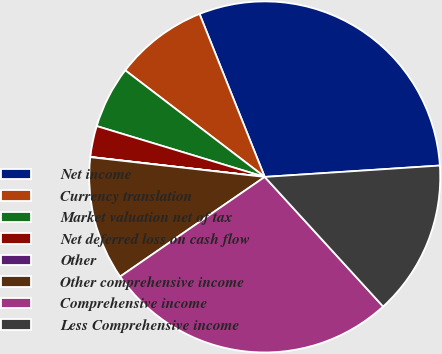Convert chart. <chart><loc_0><loc_0><loc_500><loc_500><pie_chart><fcel>Net income<fcel>Currency translation<fcel>Market valuation net of tax<fcel>Net deferred loss on cash flow<fcel>Other<fcel>Other comprehensive income<fcel>Comprehensive income<fcel>Less Comprehensive income<nl><fcel>30.02%<fcel>8.56%<fcel>5.71%<fcel>2.86%<fcel>0.02%<fcel>11.4%<fcel>27.18%<fcel>14.25%<nl></chart> 